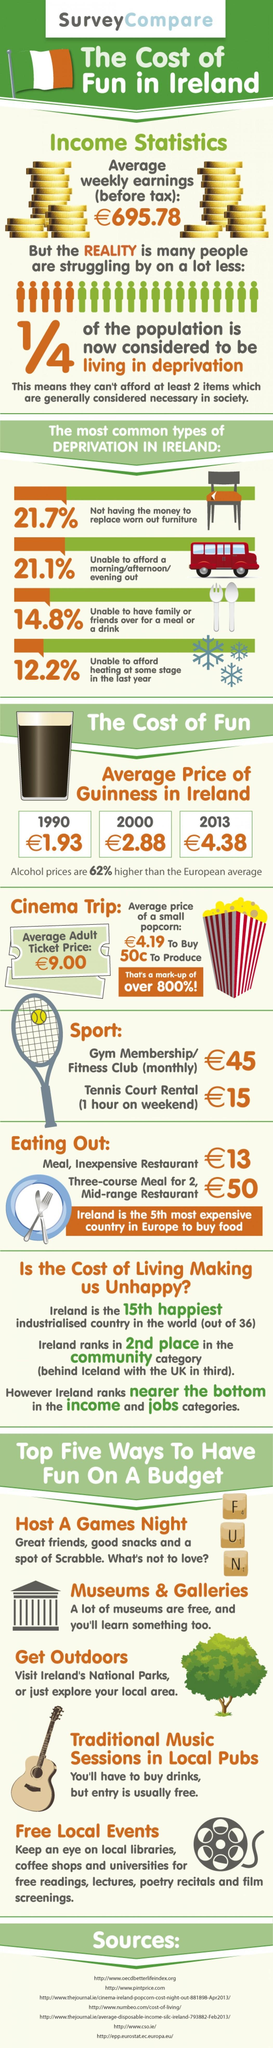In which year was a Guinness priced at 1.93?
Answer the question with a short phrase. 1990 What is listed second as a way to have fun on a budget? Museums & Galleries Which board game has been mentioned as a way to have fun? Scrabble 